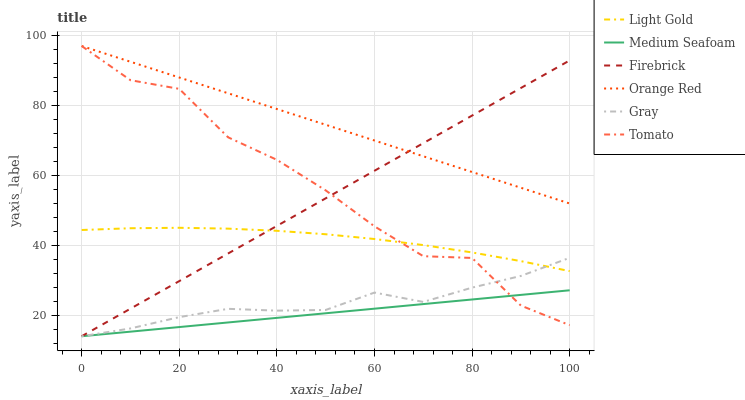Does Gray have the minimum area under the curve?
Answer yes or no. No. Does Gray have the maximum area under the curve?
Answer yes or no. No. Is Gray the smoothest?
Answer yes or no. No. Is Gray the roughest?
Answer yes or no. No. Does Orange Red have the lowest value?
Answer yes or no. No. Does Gray have the highest value?
Answer yes or no. No. Is Medium Seafoam less than Light Gold?
Answer yes or no. Yes. Is Light Gold greater than Medium Seafoam?
Answer yes or no. Yes. Does Medium Seafoam intersect Light Gold?
Answer yes or no. No. 